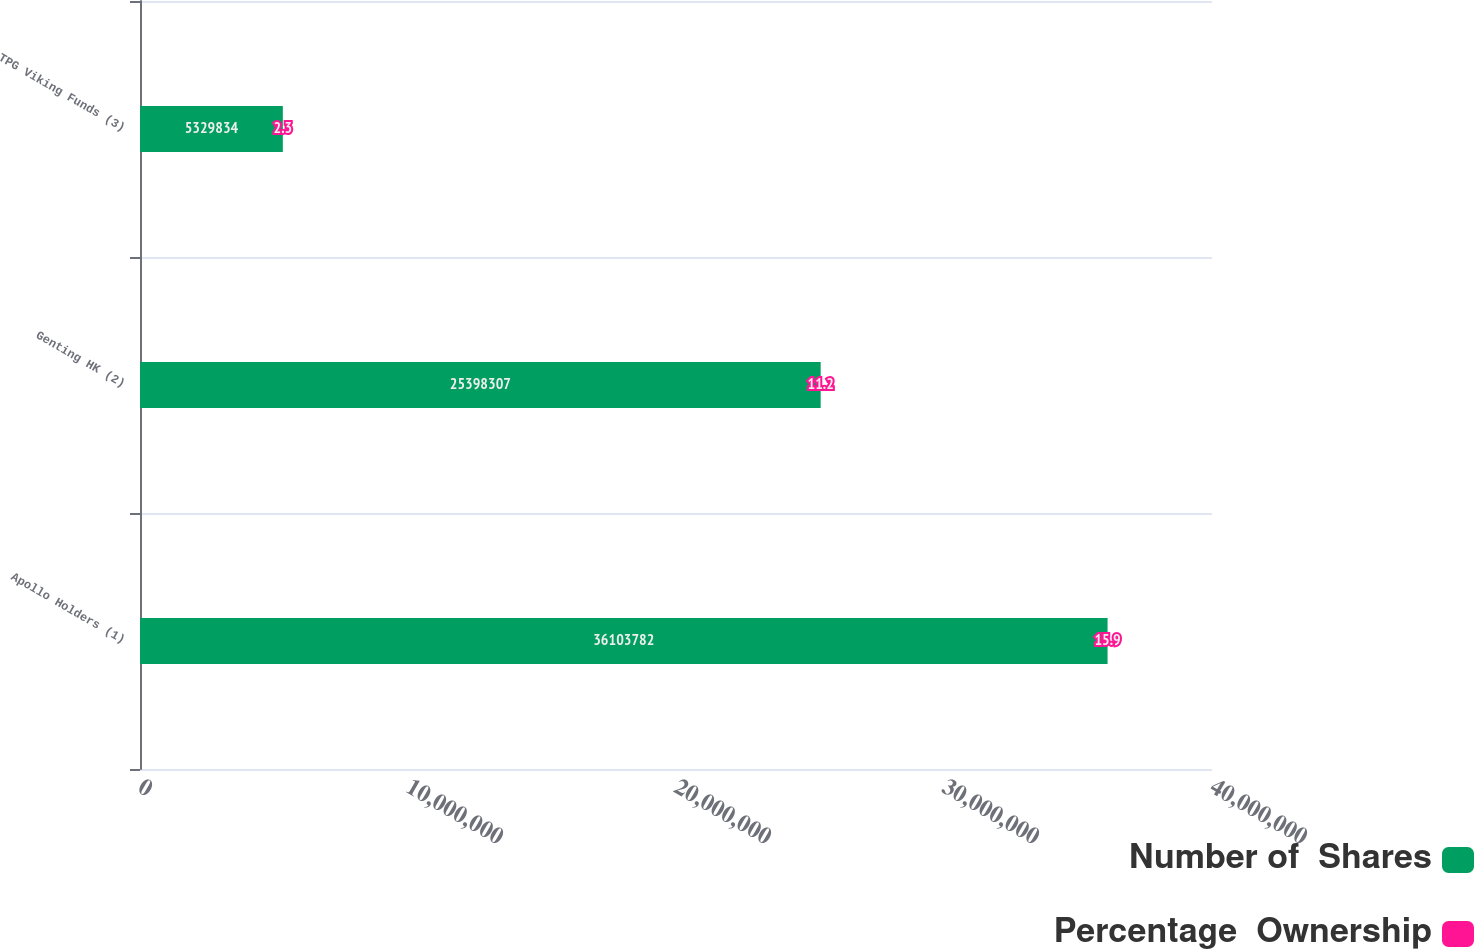Convert chart. <chart><loc_0><loc_0><loc_500><loc_500><stacked_bar_chart><ecel><fcel>Apollo Holders (1)<fcel>Genting HK (2)<fcel>TPG Viking Funds (3)<nl><fcel>Number of  Shares<fcel>3.61038e+07<fcel>2.53983e+07<fcel>5.32983e+06<nl><fcel>Percentage  Ownership<fcel>15.9<fcel>11.2<fcel>2.3<nl></chart> 